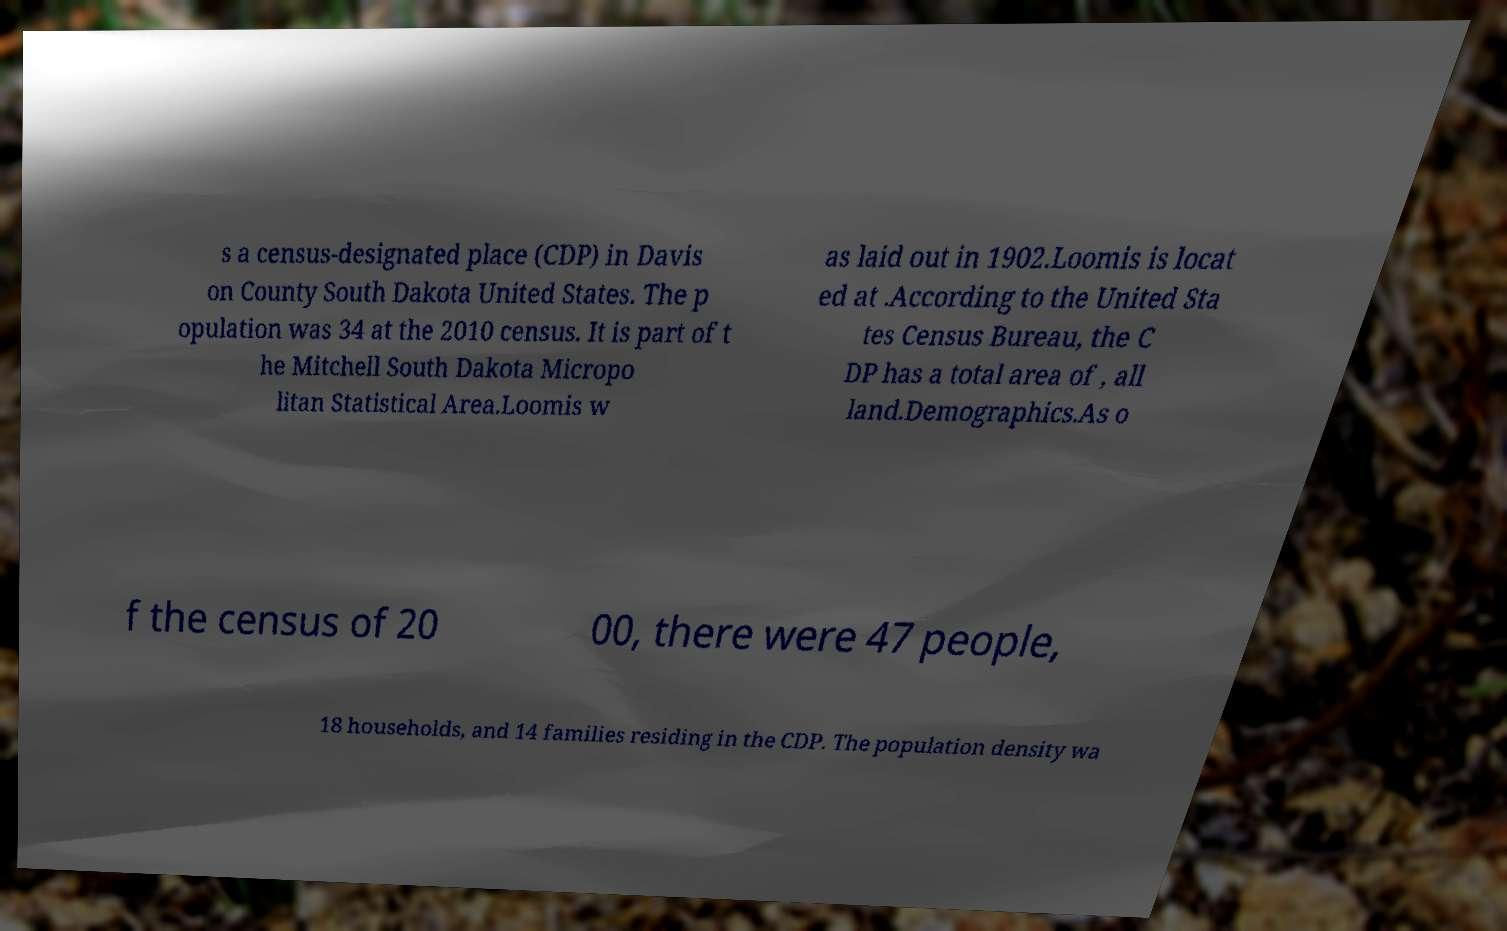I need the written content from this picture converted into text. Can you do that? s a census-designated place (CDP) in Davis on County South Dakota United States. The p opulation was 34 at the 2010 census. It is part of t he Mitchell South Dakota Micropo litan Statistical Area.Loomis w as laid out in 1902.Loomis is locat ed at .According to the United Sta tes Census Bureau, the C DP has a total area of , all land.Demographics.As o f the census of 20 00, there were 47 people, 18 households, and 14 families residing in the CDP. The population density wa 